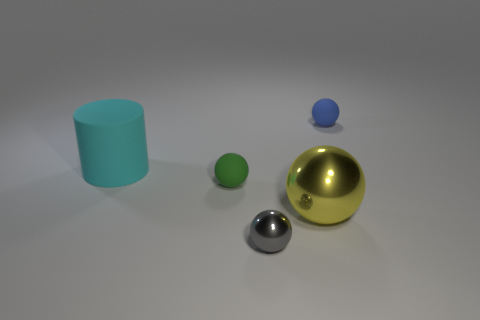Subtract all red spheres. Subtract all red cylinders. How many spheres are left? 4 Add 4 yellow metal things. How many objects exist? 9 Subtract all cylinders. How many objects are left? 4 Subtract 0 cyan balls. How many objects are left? 5 Subtract all tiny gray metal objects. Subtract all small blue objects. How many objects are left? 3 Add 5 small green balls. How many small green balls are left? 6 Add 5 small gray metallic spheres. How many small gray metallic spheres exist? 6 